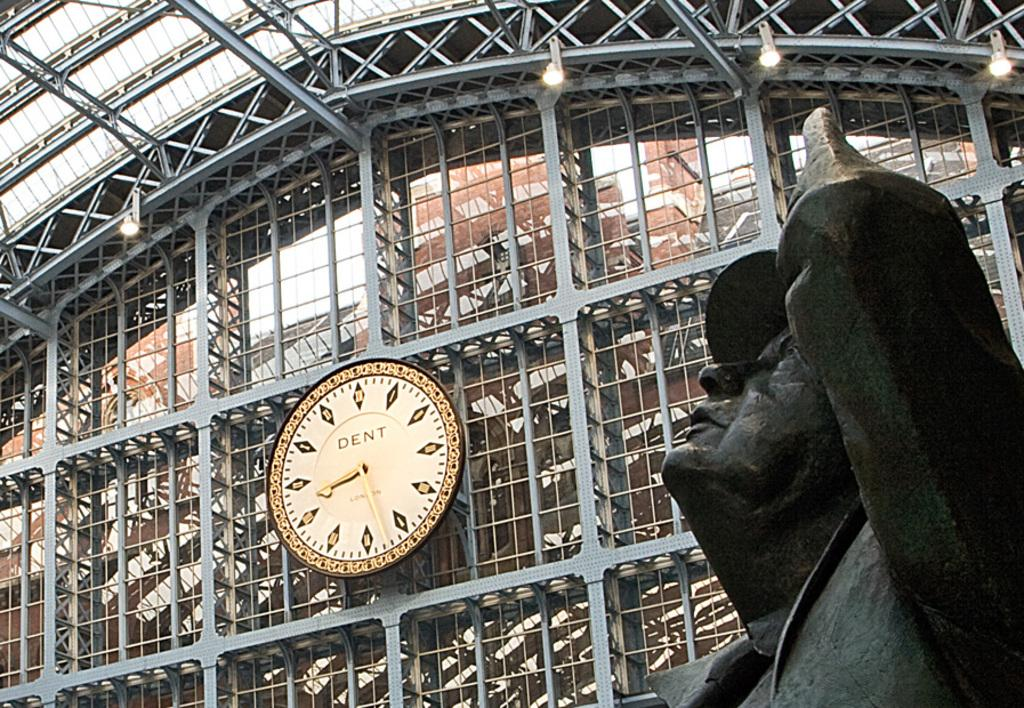<image>
Summarize the visual content of the image. The Dent clock is visible above the statue. 